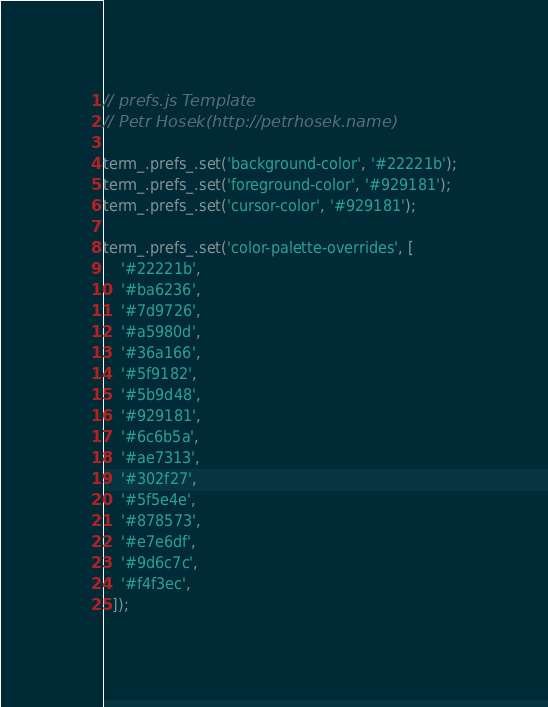<code> <loc_0><loc_0><loc_500><loc_500><_JavaScript_>// prefs.js Template
// Petr Hosek(http://petrhosek.name)

term_.prefs_.set('background-color', '#22221b');
term_.prefs_.set('foreground-color', '#929181');
term_.prefs_.set('cursor-color', '#929181');

term_.prefs_.set('color-palette-overrides', [
    '#22221b',
    '#ba6236',
    '#7d9726',
    '#a5980d',
    '#36a166',
    '#5f9182',
    '#5b9d48',
    '#929181',
    '#6c6b5a',
    '#ae7313',
    '#302f27',
    '#5f5e4e',
    '#878573',
    '#e7e6df',
    '#9d6c7c',
    '#f4f3ec',
  ]);
</code> 